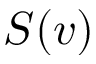<formula> <loc_0><loc_0><loc_500><loc_500>S ( v )</formula> 